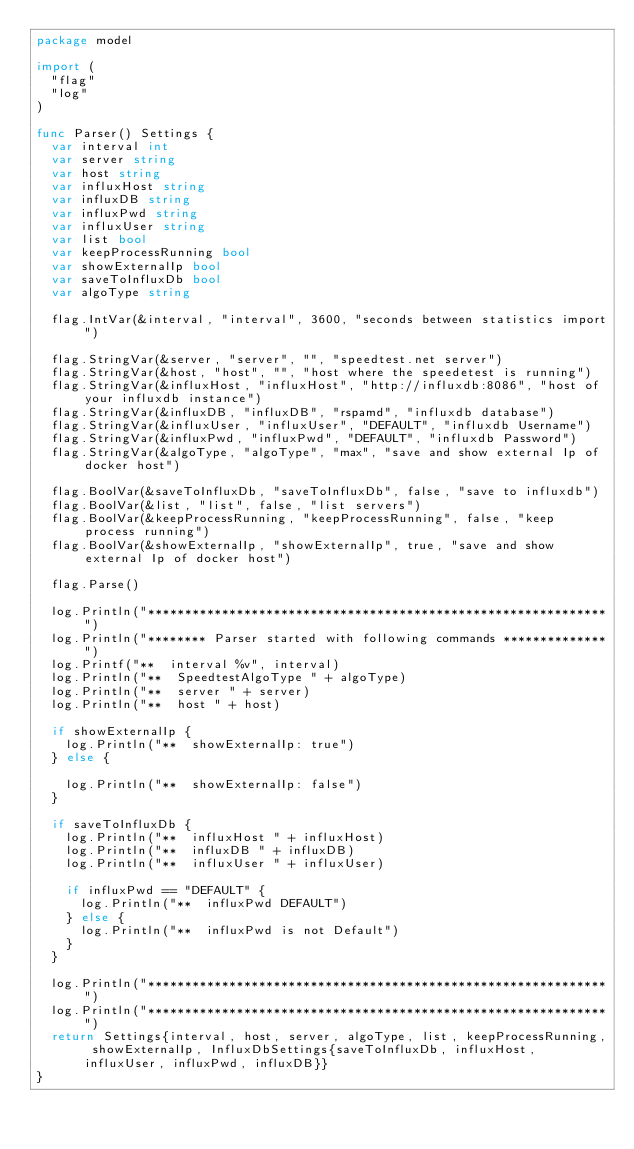<code> <loc_0><loc_0><loc_500><loc_500><_Go_>package model

import (
	"flag"
	"log"
)

func Parser() Settings {
	var interval int
	var server string
	var host string
	var influxHost string
	var influxDB string
	var influxPwd string
	var influxUser string
	var list bool
	var keepProcessRunning bool
	var showExternalIp bool
	var saveToInfluxDb bool
	var algoType string

	flag.IntVar(&interval, "interval", 3600, "seconds between statistics import")

	flag.StringVar(&server, "server", "", "speedtest.net server")
	flag.StringVar(&host, "host", "", "host where the speedetest is running")
	flag.StringVar(&influxHost, "influxHost", "http://influxdb:8086", "host of your influxdb instance")
	flag.StringVar(&influxDB, "influxDB", "rspamd", "influxdb database")
	flag.StringVar(&influxUser, "influxUser", "DEFAULT", "influxdb Username")
	flag.StringVar(&influxPwd, "influxPwd", "DEFAULT", "influxdb Password")
	flag.StringVar(&algoType, "algoType", "max", "save and show external Ip of docker host")

	flag.BoolVar(&saveToInfluxDb, "saveToInfluxDb", false, "save to influxdb")
	flag.BoolVar(&list, "list", false, "list servers")
	flag.BoolVar(&keepProcessRunning, "keepProcessRunning", false, "keep process running")
	flag.BoolVar(&showExternalIp, "showExternalIp", true, "save and show external Ip of docker host")

	flag.Parse()

	log.Println("**************************************************************")
	log.Println("******** Parser started with following commands **************")
	log.Printf("**  interval %v", interval)
	log.Println("**  SpeedtestAlgoType " + algoType)
	log.Println("**  server " + server)
	log.Println("**  host " + host)

	if showExternalIp {
		log.Println("**  showExternalIp: true")
	} else {

		log.Println("**  showExternalIp: false")
	}

	if saveToInfluxDb {
		log.Println("**  influxHost " + influxHost)
		log.Println("**  influxDB " + influxDB)
		log.Println("**  influxUser " + influxUser)

		if influxPwd == "DEFAULT" {
			log.Println("**  influxPwd DEFAULT")
		} else {
			log.Println("**  influxPwd is not Default")
		}
	}

	log.Println("**************************************************************")
	log.Println("**************************************************************")
	return Settings{interval, host, server, algoType, list, keepProcessRunning, showExternalIp, InfluxDbSettings{saveToInfluxDb, influxHost, influxUser, influxPwd, influxDB}}
}
</code> 